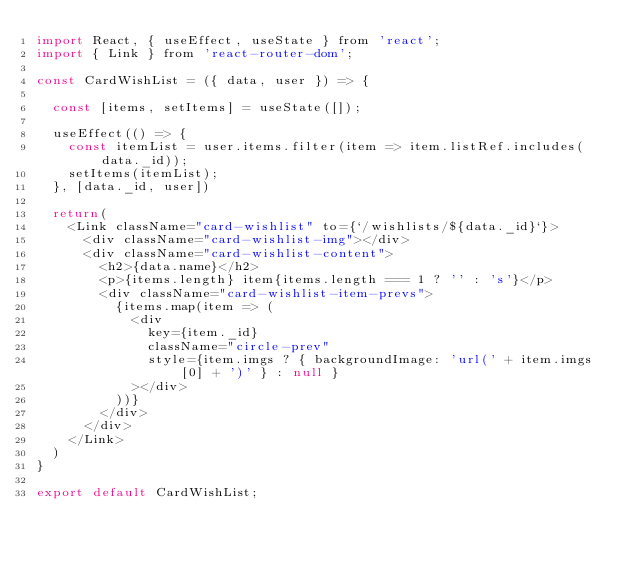Convert code to text. <code><loc_0><loc_0><loc_500><loc_500><_JavaScript_>import React, { useEffect, useState } from 'react';
import { Link } from 'react-router-dom';

const CardWishList = ({ data, user }) => {

  const [items, setItems] = useState([]);

  useEffect(() => {
    const itemList = user.items.filter(item => item.listRef.includes(data._id));
    setItems(itemList);
  }, [data._id, user])

  return(
    <Link className="card-wishlist" to={`/wishlists/${data._id}`}>
      <div className="card-wishlist-img"></div>
      <div className="card-wishlist-content">
        <h2>{data.name}</h2>
        <p>{items.length} item{items.length === 1 ? '' : 's'}</p>
        <div className="card-wishlist-item-prevs">
          {items.map(item => (
            <div
              key={item._id}
              className="circle-prev"
              style={item.imgs ? { backgroundImage: 'url(' + item.imgs[0] + ')' } : null }
            ></div>
          ))}
        </div>
      </div>
    </Link>
  )
}

export default CardWishList;</code> 